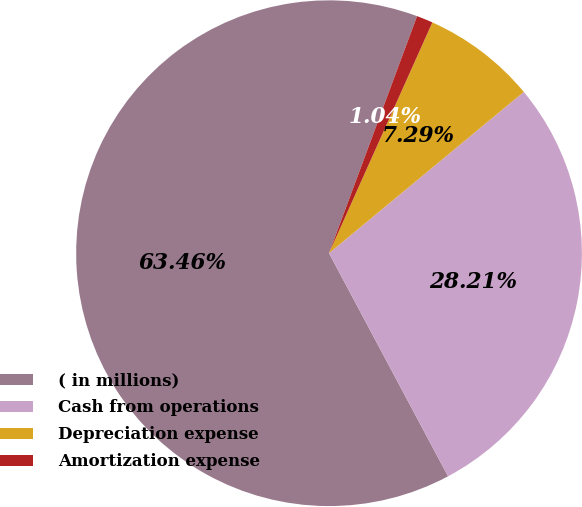<chart> <loc_0><loc_0><loc_500><loc_500><pie_chart><fcel>( in millions)<fcel>Cash from operations<fcel>Depreciation expense<fcel>Amortization expense<nl><fcel>63.46%<fcel>28.21%<fcel>7.29%<fcel>1.04%<nl></chart> 